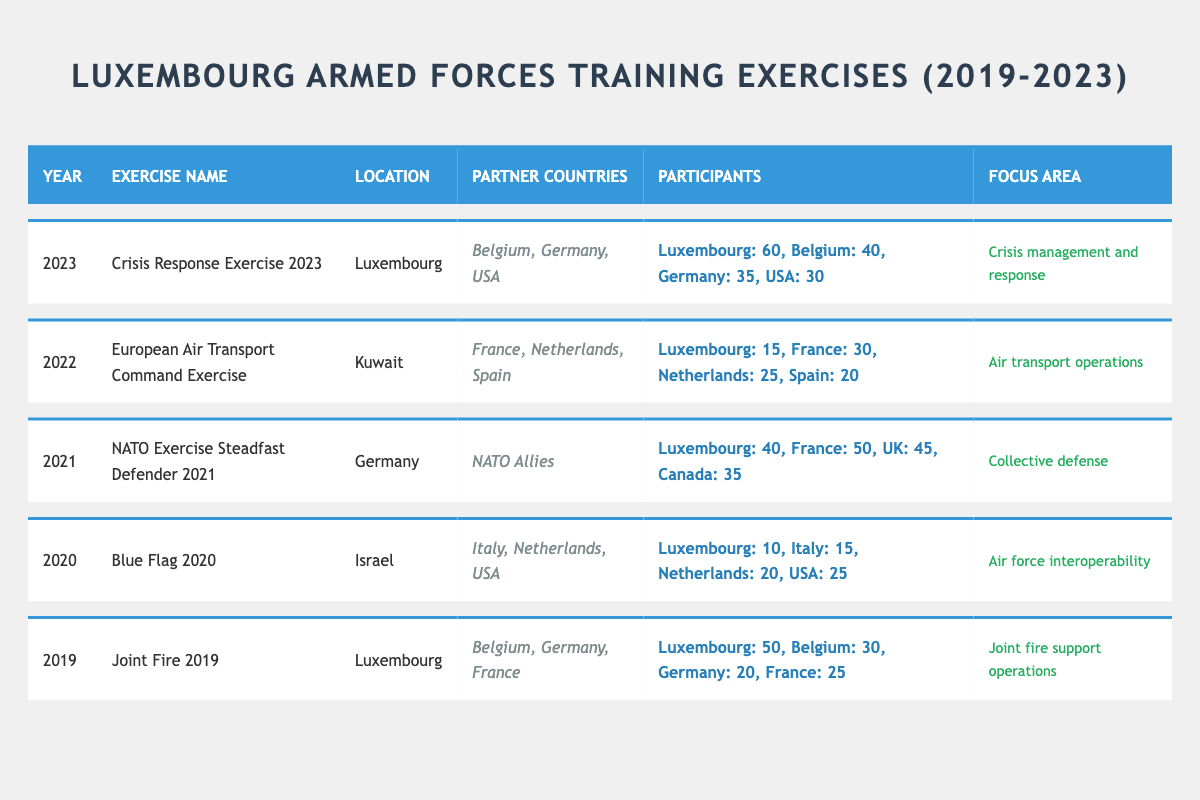What was the focus area of the exercise in 2021? The exercise in 2021 was "NATO Exercise Steadfast Defender 2021," and the focus area listed is "Collective defense."
Answer: Collective defense How many participants from France took part in the "Crisis Response Exercise 2023"? The "Crisis Response Exercise 2023" had 30 participants from France listed in the table.
Answer: 30 Which exercise had the highest number of Luxembourg participants? By comparing the number of participants for Luxembourg across all exercises, "Crisis Response Exercise 2023" has 60 participants, which is the highest.
Answer: 60 What is the total number of participants from Luxembourg, Belgium, and Germany in the "European Air Transport Command Exercise"? Adding the participants: Luxembourg (15) + Belgium (0) + Germany (0) = 15 for Luxembourg, 30 for France, 25 for Netherlands, and 20 for Spain, but Belgium and Germany did not participate in this exercise, leading to a total of 15 for Luxembourg only.
Answer: 15 Which exercise took place in 2022? The exercise that took place in 2022 is the "European Air Transport Command Exercise," as stated in the table under the year 2022.
Answer: European Air Transport Command Exercise Did Belgium participate in any training exercises with Luxembourg? Yes, Belgium participated in multiple training exercises with Luxembourg, including "Crisis Response Exercise 2023" and "Joint Fire 2019."
Answer: Yes What was the average number of participants from Luxembourg across all training exercises? Summing all the Luxembourg participants: (50 + 10 + 40 + 15 + 60) = 175. There are 5 exercises; thus, the average is 175/5 = 35.
Answer: 35 How many partner countries were involved in the "Blue Flag 2020"? The exercise "Blue Flag 2020" had 3 listed partner countries: Italy, Netherlands, and USA.
Answer: 3 Which focus area was addressed in the “Joint Fire 2019” exercise? The focus area for the "Joint Fire 2019" exercise is "Joint fire support operations," as shown in the table.
Answer: Joint fire support operations Was there any exercise conducted in Luxembourg in 2020? The table does not show any exercises conducted in Luxembourg in 2020; the closest year is 2019 and 2023.
Answer: No 